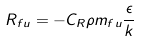<formula> <loc_0><loc_0><loc_500><loc_500>R _ { f u } = - C _ { R } \rho m _ { f u } \frac { \epsilon } { k }</formula> 